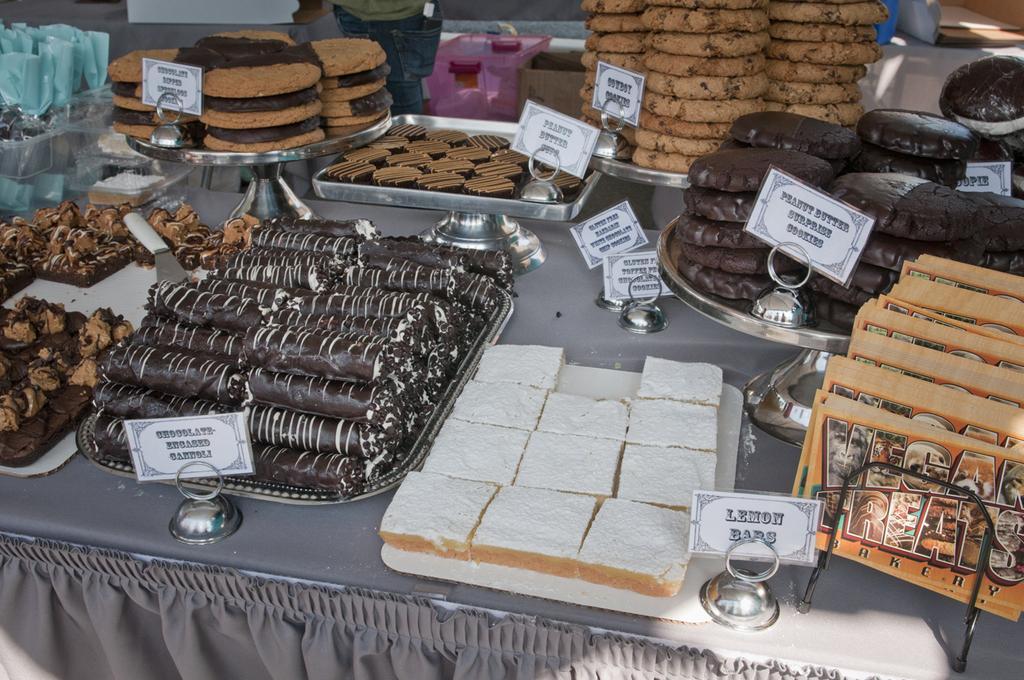Can you describe this image briefly? In this image there are cakes and some food items , papers on the circular trays and plates with the name boards , knife and some objects on the table, and at the background there is a person. 